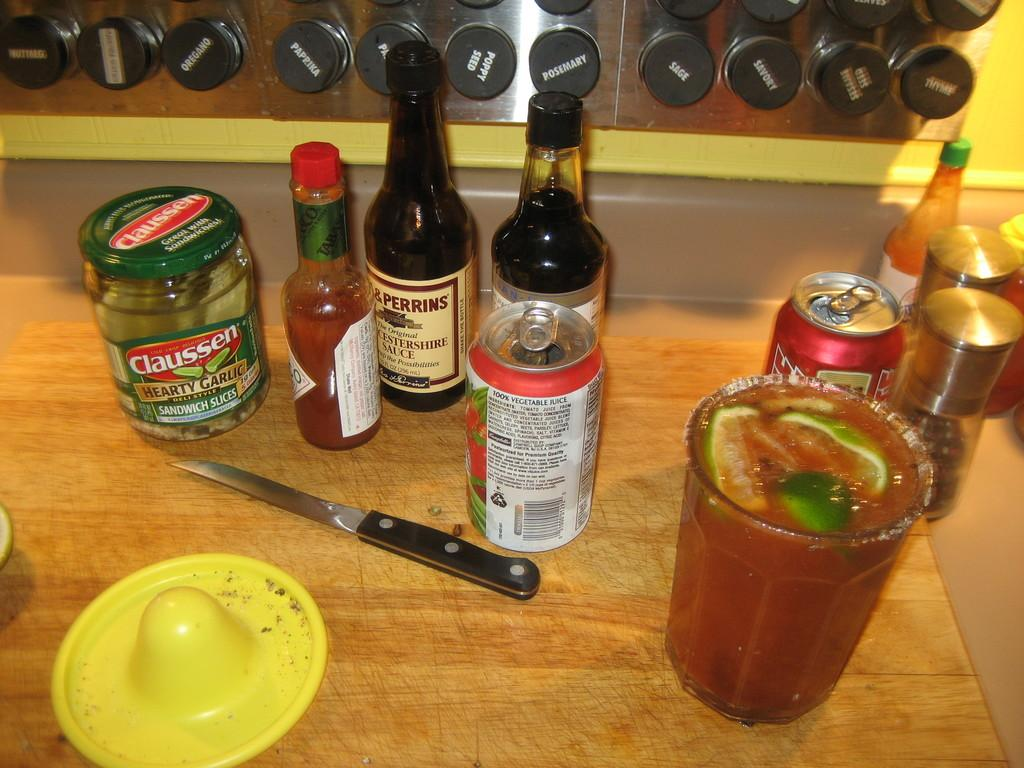<image>
Summarize the visual content of the image. Several bottles and cans are on a board as well as a jar of Claussen Sandwich Slices. 